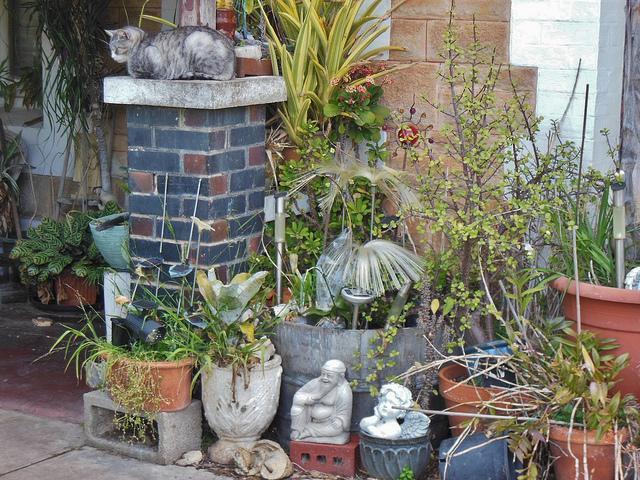What is the little angel in the flower pot called?
Indicate the correct choice and explain in the format: 'Answer: answer
Rationale: rationale.'
Options: Raphael, gabriel, cherub, michael. Answer: cherub.
Rationale: That's what they call the littlest angel. 